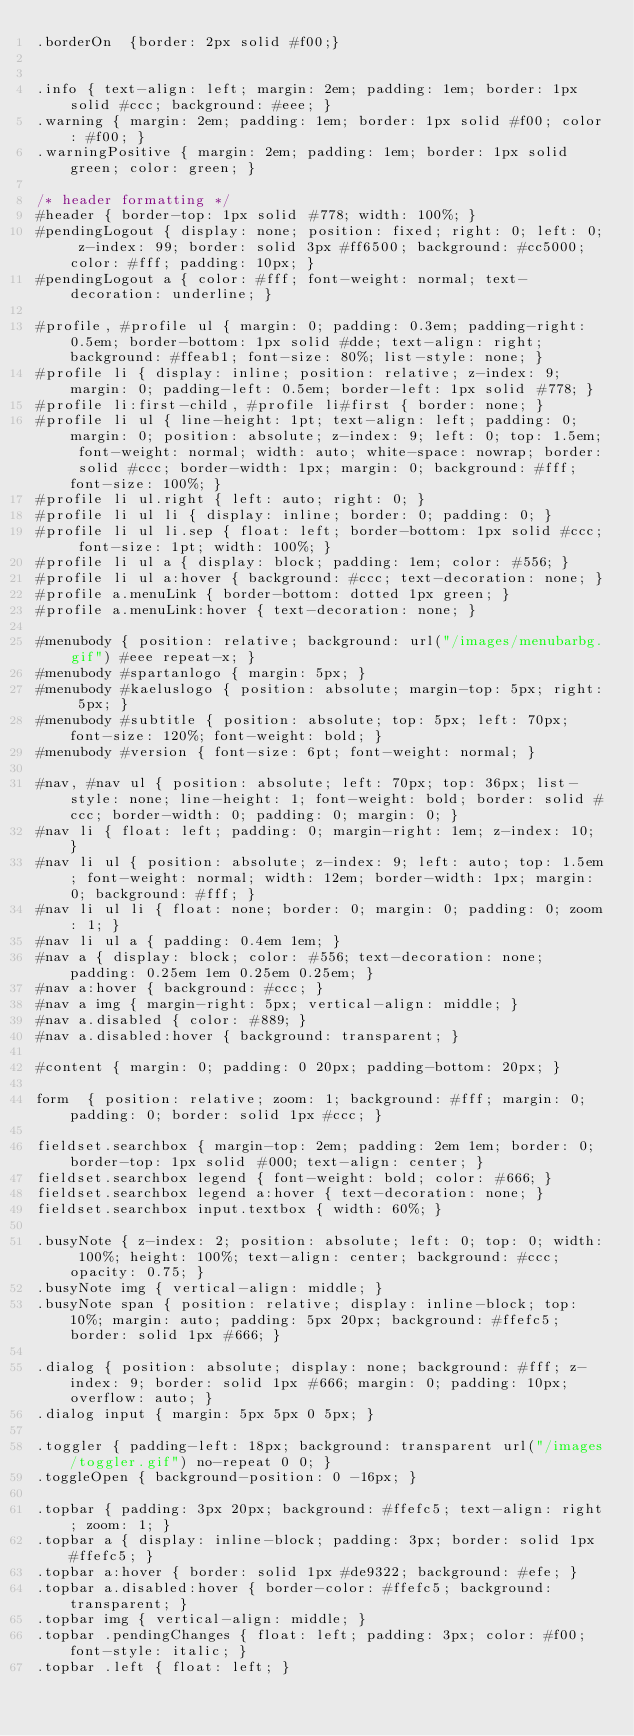<code> <loc_0><loc_0><loc_500><loc_500><_CSS_>.borderOn  {border: 2px solid #f00;}


.info { text-align: left; margin: 2em; padding: 1em; border: 1px solid #ccc; background: #eee; }
.warning { margin: 2em; padding: 1em; border: 1px solid #f00; color: #f00; }
.warningPositive { margin: 2em; padding: 1em; border: 1px solid green; color: green; }

/* header formatting */
#header { border-top: 1px solid #778; width: 100%; }
#pendingLogout { display: none; position: fixed; right: 0; left: 0; z-index: 99; border: solid 3px #ff6500; background: #cc5000; color: #fff; padding: 10px; }
#pendingLogout a { color: #fff; font-weight: normal; text-decoration: underline; }

#profile, #profile ul { margin: 0; padding: 0.3em; padding-right: 0.5em; border-bottom: 1px solid #dde; text-align: right; background: #ffeab1; font-size: 80%; list-style: none; }
#profile li { display: inline; position: relative; z-index: 9; margin: 0; padding-left: 0.5em; border-left: 1px solid #778; }
#profile li:first-child, #profile li#first { border: none; }
#profile li ul { line-height: 1pt; text-align: left; padding: 0; margin: 0; position: absolute; z-index: 9; left: 0; top: 1.5em; font-weight: normal; width: auto; white-space: nowrap; border: solid #ccc; border-width: 1px; margin: 0; background: #fff; font-size: 100%; }
#profile li ul.right { left: auto; right: 0; }
#profile li ul li { display: inline; border: 0; padding: 0; }
#profile li ul li.sep { float: left; border-bottom: 1px solid #ccc; font-size: 1pt; width: 100%; }
#profile li ul a { display: block; padding: 1em; color: #556; }
#profile li ul a:hover { background: #ccc; text-decoration: none; }
#profile a.menuLink { border-bottom: dotted 1px green; }
#profile a.menuLink:hover { text-decoration: none; }

#menubody { position: relative; background: url("/images/menubarbg.gif") #eee repeat-x; }
#menubody #spartanlogo { margin: 5px; }
#menubody #kaeluslogo { position: absolute; margin-top: 5px; right: 5px; }
#menubody #subtitle { position: absolute; top: 5px; left: 70px; font-size: 120%; font-weight: bold; }
#menubody #version { font-size: 6pt; font-weight: normal; }

#nav, #nav ul {	position: absolute; left: 70px; top: 36px; list-style: none; line-height: 1; font-weight: bold; border: solid #ccc;	border-width: 0; padding: 0; margin: 0; }
#nav li { float: left; padding: 0; margin-right: 1em; z-index: 10; }
#nav li ul { position: absolute; z-index: 9; left: auto; top: 1.5em; font-weight: normal; width: 12em; border-width: 1px; margin: 0; background: #fff; }
#nav li ul li { float: none; border: 0; margin: 0; padding: 0; zoom: 1; }
#nav li ul a { padding: 0.4em 1em; }
#nav a { display: block; color: #556; text-decoration: none; padding: 0.25em 1em 0.25em 0.25em; }
#nav a:hover { background: #ccc; }
#nav a img { margin-right: 5px; vertical-align: middle; }
#nav a.disabled { color: #889; }
#nav a.disabled:hover { background: transparent; }

#content { margin: 0; padding: 0 20px; padding-bottom: 20px; }

form  { position: relative; zoom: 1; background: #fff; margin: 0; padding: 0; border: solid 1px #ccc; }

fieldset.searchbox { margin-top: 2em; padding: 2em 1em; border: 0; border-top: 1px solid #000; text-align: center; }
fieldset.searchbox legend { font-weight: bold; color: #666; }
fieldset.searchbox legend a:hover { text-decoration: none; }
fieldset.searchbox input.textbox { width: 60%; }

.busyNote { z-index: 2; position: absolute; left: 0; top: 0; width: 100%; height: 100%; text-align: center; background: #ccc; opacity: 0.75; }
.busyNote img { vertical-align: middle; }
.busyNote span { position: relative; display: inline-block; top: 10%; margin: auto; padding: 5px 20px; background: #ffefc5; border: solid 1px #666; }

.dialog { position: absolute; display: none; background: #fff; z-index: 9; border: solid 1px #666; margin: 0; padding: 10px; overflow: auto; }
.dialog input { margin: 5px 5px 0 5px; }

.toggler { padding-left: 18px; background: transparent url("/images/toggler.gif") no-repeat 0 0; }
.toggleOpen { background-position: 0 -16px; }

.topbar { padding: 3px 20px; background: #ffefc5; text-align: right; zoom: 1; }
.topbar a { display: inline-block; padding: 3px; border: solid 1px #ffefc5; }
.topbar a:hover { border: solid 1px #de9322; background: #efe; }
.topbar a.disabled:hover { border-color: #ffefc5; background: transparent; }
.topbar img { vertical-align: middle; }
.topbar .pendingChanges { float: left; padding: 3px; color: #f00; font-style: italic; }
.topbar .left { float: left; }</code> 